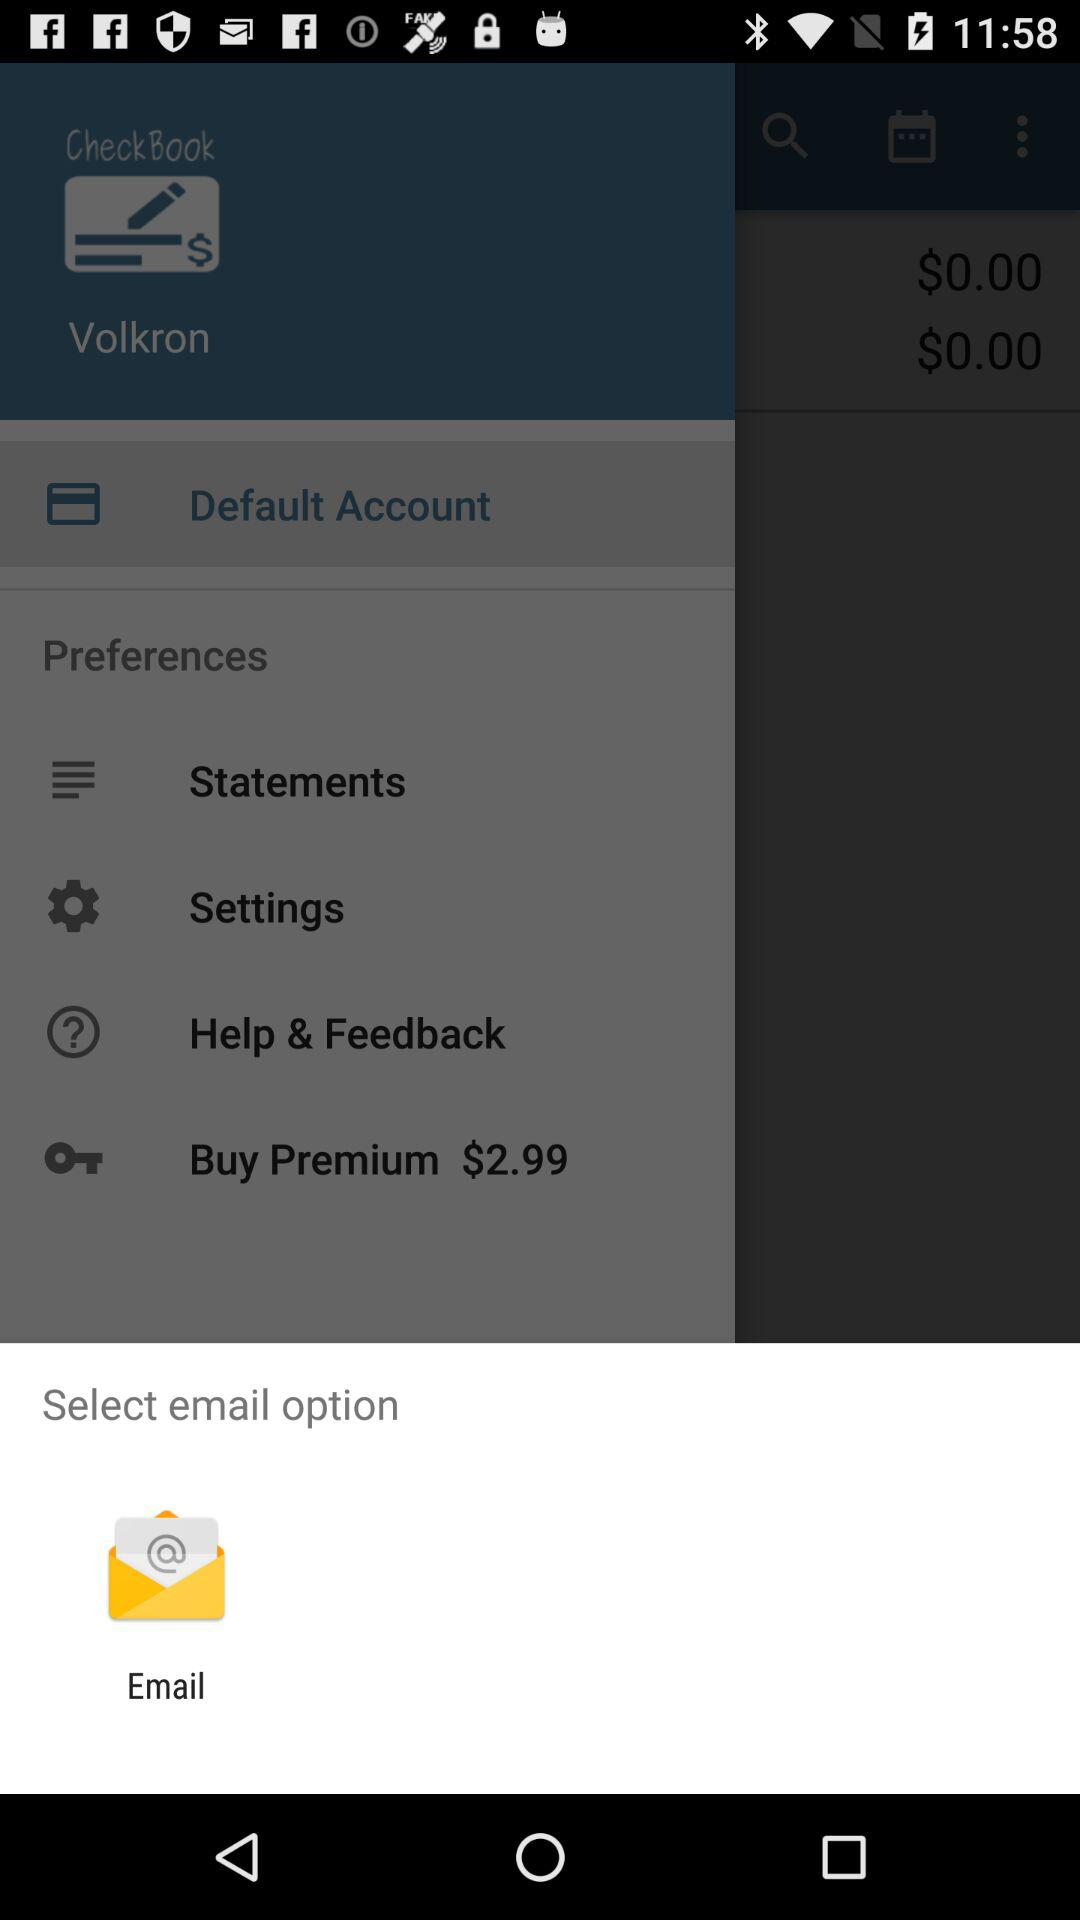How much more is the price of the Buy Premium item than the price of the Default Account item?
Answer the question using a single word or phrase. $2.99 